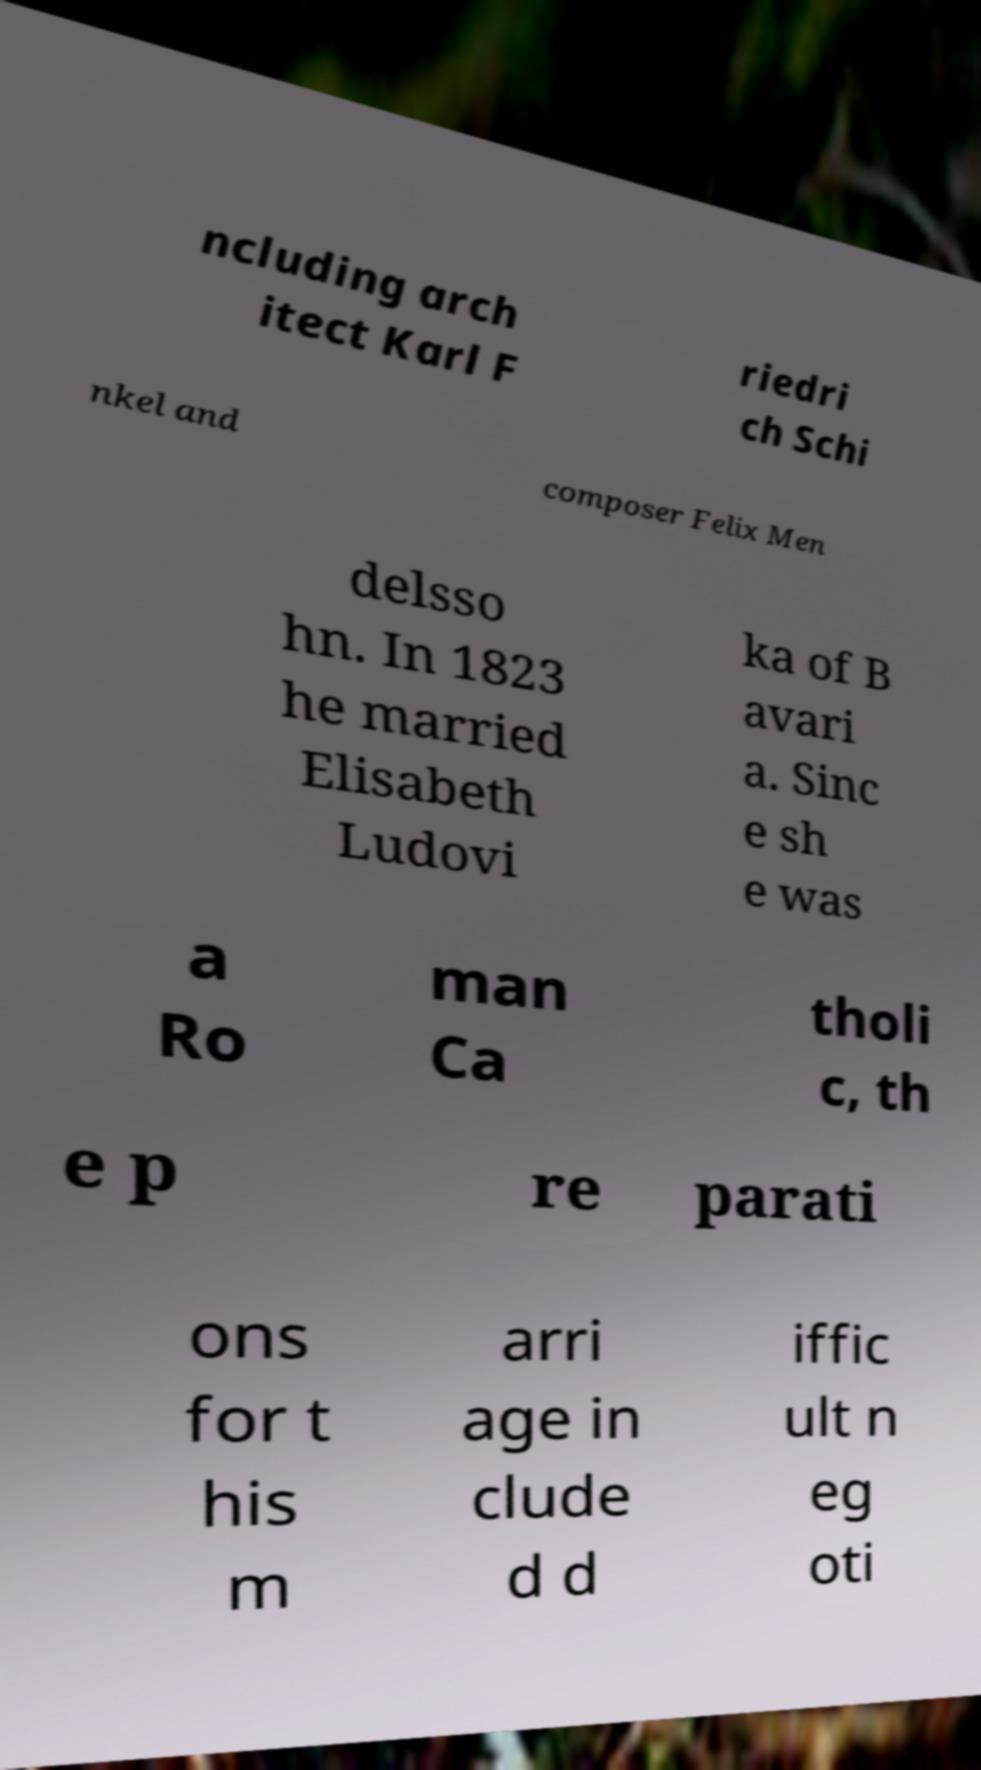For documentation purposes, I need the text within this image transcribed. Could you provide that? ncluding arch itect Karl F riedri ch Schi nkel and composer Felix Men delsso hn. In 1823 he married Elisabeth Ludovi ka of B avari a. Sinc e sh e was a Ro man Ca tholi c, th e p re parati ons for t his m arri age in clude d d iffic ult n eg oti 